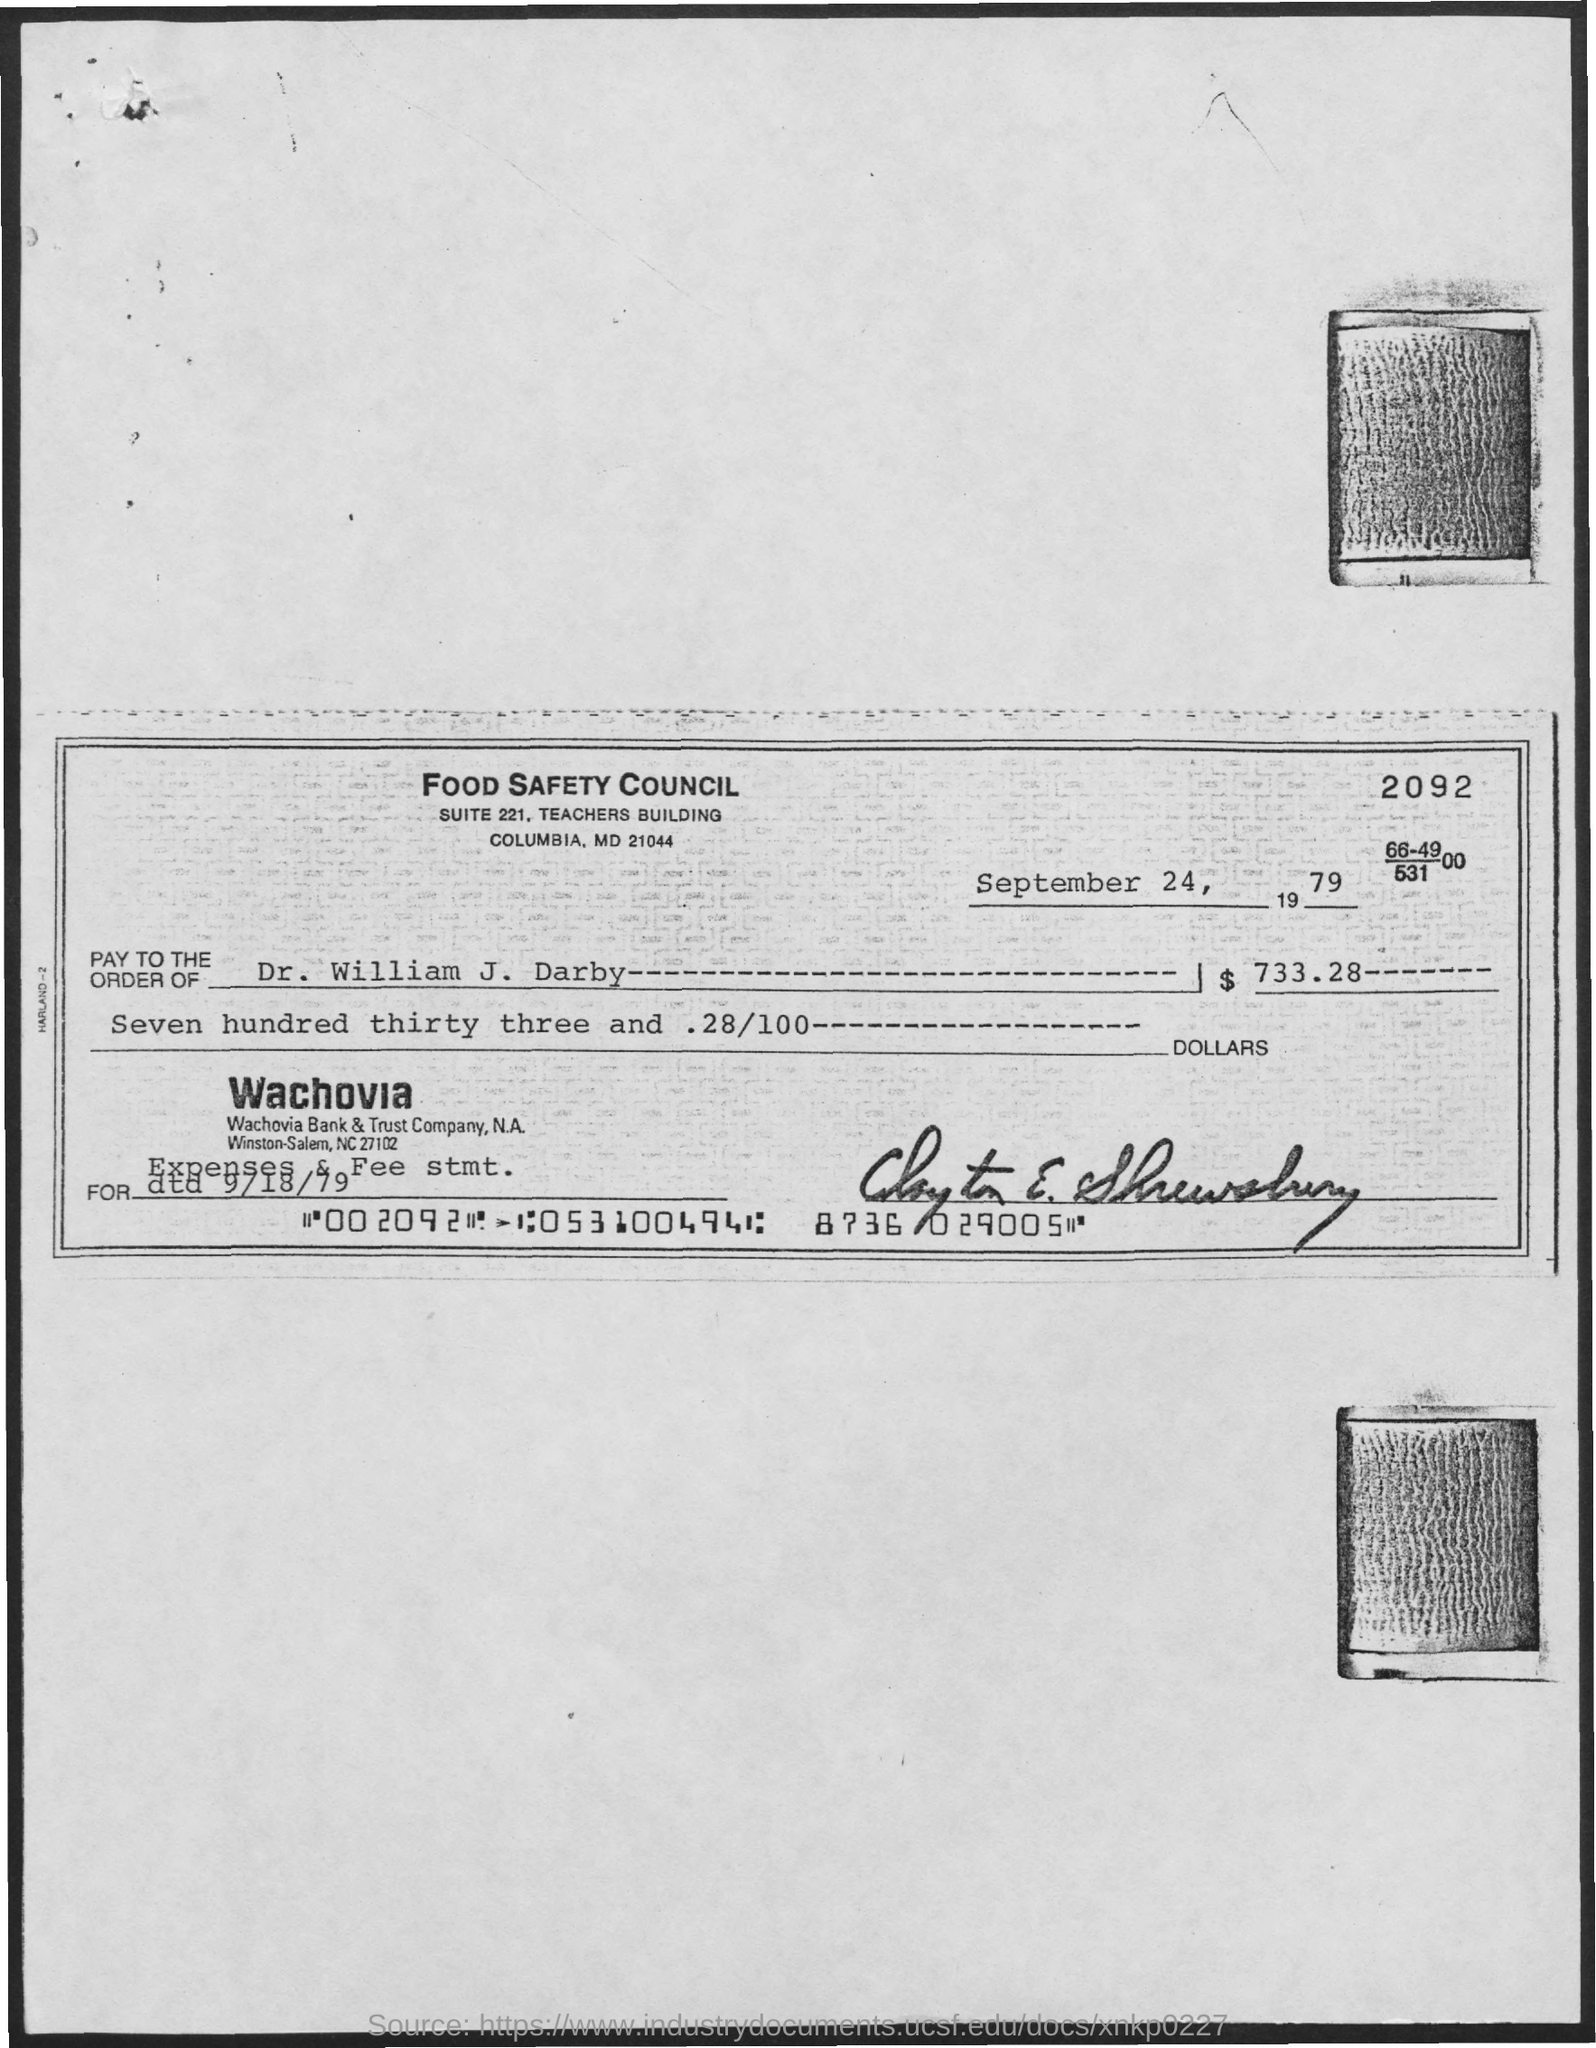Indicate a few pertinent items in this graphic. The cheque was issued on September 24, 1979. I hereby declare that the name of the council is the FOOD SAFETY COUNCIL. The amount in the cheque is $733.28. The recipient of the check is Dr. William J. Darby. The address of the Food Safety Council is located in Suite 221 of the Teachers Building in Columbia, Maryland, which can be found at 21044. 